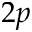Convert formula to latex. <formula><loc_0><loc_0><loc_500><loc_500>2 p</formula> 